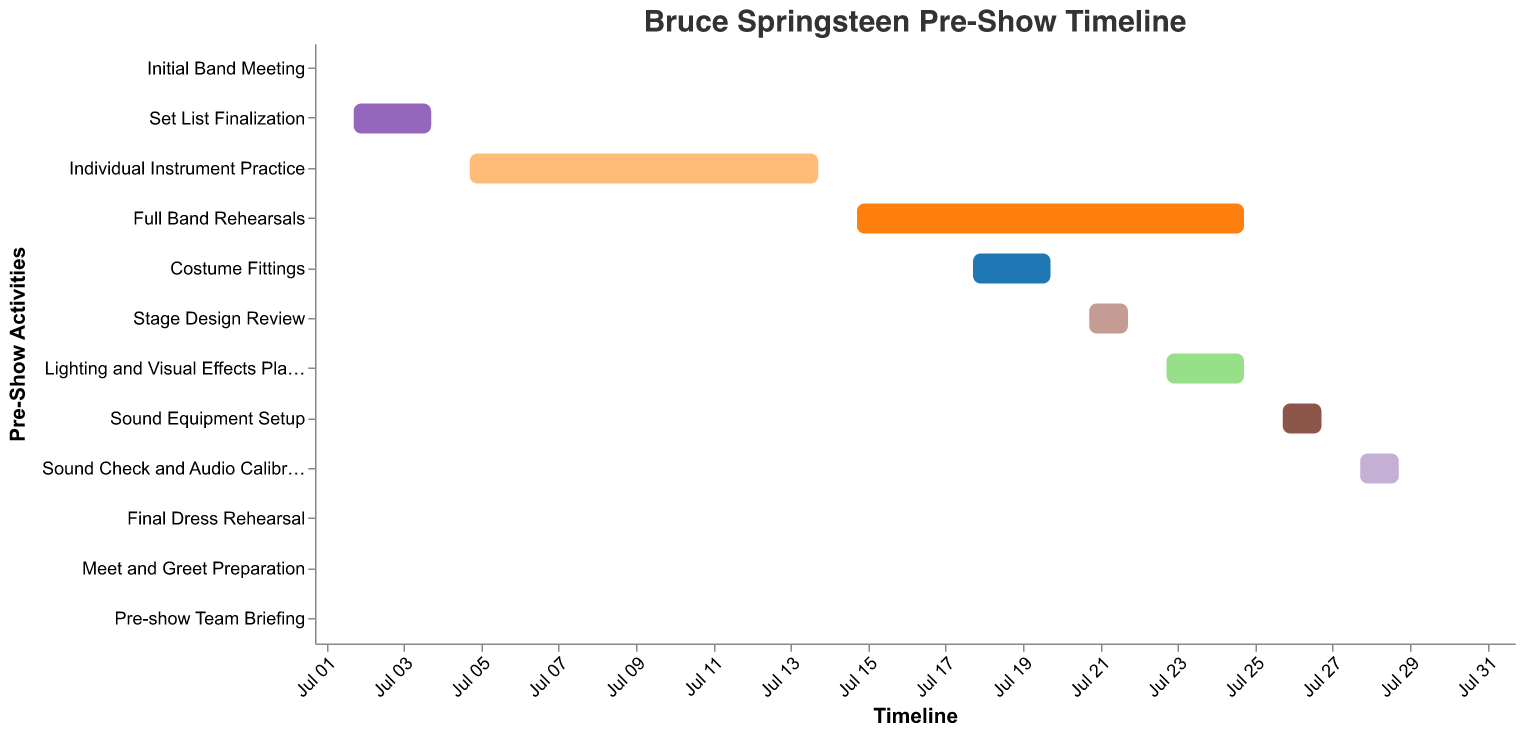What's the duration of the "Full Band Rehearsals"? To find the duration of "Full Band Rehearsals," look at the start and end dates. It begins on July 15 and ends on July 25. The duration is the number of days between these dates, inclusive.
Answer: 11 days When does the "Sound Equipment Setup" occur? According to the timeline, "Sound Equipment Setup" starts on July 26 and ends on July 27.
Answer: July 26 - July 27 Which tasks are happening concurrently with "Full Band Rehearsals"? Look at other tasks' dates overlapping with the "Full Band Rehearsals" (July 15 - July 25). "Costume Fittings" (July 18 - July 20) and "Lighting and Visual Effects Planning" (July 23 - July 25) occur during this period.
Answer: Costume Fittings, Lighting and Visual Effects Planning How many tasks are scheduled for a single day at most? Identify the day with the maximum tasks by checking overlaps. For example, July 23 has "Full Band Rehearsals" and "Lighting and Visual Effects Planning".
Answer: 2 tasks What is the gap between "Initial Band Meeting" and "Set List Finalization"? The "Initial Band Meeting" occurs on July 1, and "Set List Finalization" starts on July 2. The gap between these tasks is 1 day.
Answer: 1 day Which task has the longest duration? Compare the duration of each task by counting days between their start and end dates. "Individual Instrument Practice" spans the longest, from July 5 to July 14.
Answer: Individual Instrument Practice Is any task scheduled to start immediately after "Final Dress Rehearsal"? "Final Dress Rehearsal" ends on July 30. "Meet and Greet Preparation" starts on July 31.
Answer: Yes What comes before "Pre-show Team Briefing"? "Pre-show Team Briefing" is on August 1. The task before this is "Meet and Greet Preparation" on July 31.
Answer: Meet and Greet Preparation How many tasks are completed by July 20? Check tasks ending by July 20. These are "Initial Band Meeting", "Set List Finalization", "Individual Instrument Practice", "Full Band Rehearsals", and "Costume Fittings".
Answer: 5 tasks When do planning tasks like "Lighting and Visual Effects Planning" and "Stage Design Review" occur? "Stage Design Review" is from July 21 to July 22, and "Lighting and Visual Effects Planning" is from July 23 to July 25.
Answer: July 21 - July 25 